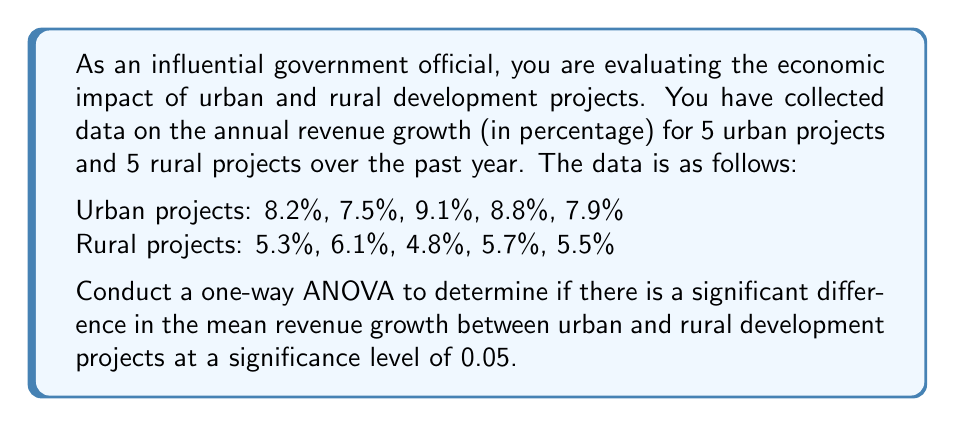Help me with this question. To conduct a one-way ANOVA, we need to follow these steps:

1. Calculate the sum of squares between groups (SSB) and within groups (SSW).
2. Calculate the degrees of freedom between groups (dfB) and within groups (dfW).
3. Calculate the mean square between groups (MSB) and within groups (MSW).
4. Calculate the F-statistic.
5. Compare the F-statistic to the critical F-value.

Step 1: Calculate SSB and SSW

First, we need to calculate the grand mean:
$$ \bar{X} = \frac{(8.2 + 7.5 + 9.1 + 8.8 + 7.9 + 5.3 + 6.1 + 4.8 + 5.7 + 5.5)}{10} = 6.89 $$

Now, we calculate the group means:
$$ \bar{X}_{\text{urban}} = \frac{(8.2 + 7.5 + 9.1 + 8.8 + 7.9)}{5} = 8.3 $$
$$ \bar{X}_{\text{rural}} = \frac{(5.3 + 6.1 + 4.8 + 5.7 + 5.5)}{5} = 5.48 $$

SSB:
$$ SSB = 5(8.3 - 6.89)^2 + 5(5.48 - 6.89)^2 = 19.881 $$

SSW:
$$ SSW_{\text{urban}} = (8.2 - 8.3)^2 + (7.5 - 8.3)^2 + (9.1 - 8.3)^2 + (8.8 - 8.3)^2 + (7.9 - 8.3)^2 = 1.856 $$
$$ SSW_{\text{rural}} = (5.3 - 5.48)^2 + (6.1 - 5.48)^2 + (4.8 - 5.48)^2 + (5.7 - 5.48)^2 + (5.5 - 5.48)^2 = 0.8872 $$
$$ SSW = SSW_{\text{urban}} + SSW_{\text{rural}} = 2.7432 $$

Step 2: Calculate degrees of freedom

$$ df_B = k - 1 = 2 - 1 = 1 $$
$$ df_W = N - k = 10 - 2 = 8 $$

Where k is the number of groups and N is the total number of observations.

Step 3: Calculate mean squares

$$ MSB = \frac{SSB}{df_B} = \frac{19.881}{1} = 19.881 $$
$$ MSW = \frac{SSW}{df_W} = \frac{2.7432}{8} = 0.3429 $$

Step 4: Calculate F-statistic

$$ F = \frac{MSB}{MSW} = \frac{19.881}{0.3429} = 57.98 $$

Step 5: Compare F-statistic to critical F-value

At a significance level of 0.05, with df_B = 1 and df_W = 8, the critical F-value is approximately 5.32.

Since our calculated F-statistic (57.98) is greater than the critical F-value (5.32), we reject the null hypothesis.
Answer: The F-statistic (57.98) is greater than the critical F-value (5.32) at a significance level of 0.05. Therefore, we reject the null hypothesis and conclude that there is a significant difference in the mean revenue growth between urban and rural development projects. 